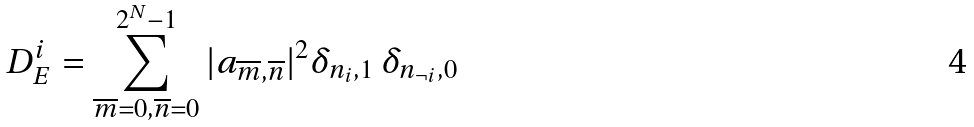<formula> <loc_0><loc_0><loc_500><loc_500>D _ { E } ^ { i } = \sum _ { \overline { m } = 0 , \overline { n } = 0 } ^ { 2 ^ { N } - 1 } | a _ { \overline { m } , \overline { n } } | ^ { 2 } \delta _ { n _ { i } , 1 } \, \delta _ { n _ { \neg i } , 0 }</formula> 